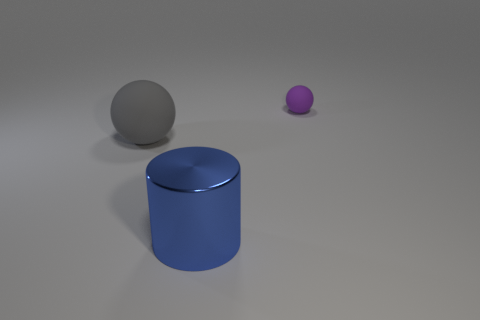Add 2 brown shiny spheres. How many objects exist? 5 Subtract all balls. How many objects are left? 1 Subtract all cylinders. Subtract all large cylinders. How many objects are left? 1 Add 3 cylinders. How many cylinders are left? 4 Add 1 matte things. How many matte things exist? 3 Subtract 0 brown blocks. How many objects are left? 3 